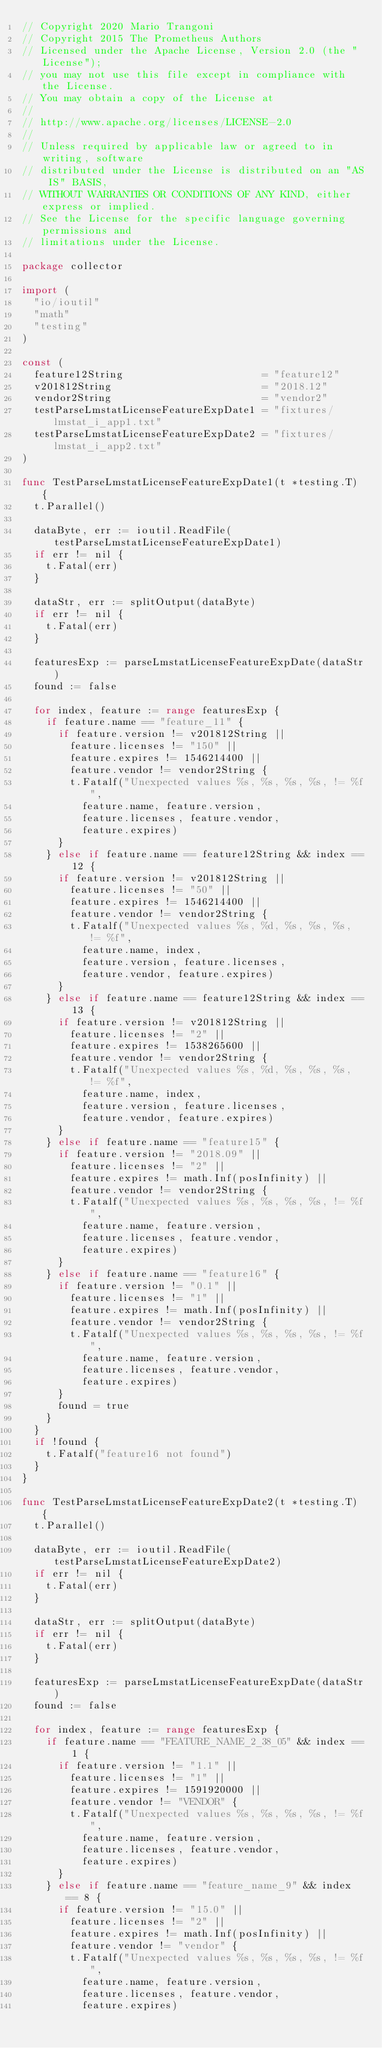<code> <loc_0><loc_0><loc_500><loc_500><_Go_>// Copyright 2020 Mario Trangoni
// Copyright 2015 The Prometheus Authors
// Licensed under the Apache License, Version 2.0 (the "License");
// you may not use this file except in compliance with the License.
// You may obtain a copy of the License at
//
// http://www.apache.org/licenses/LICENSE-2.0
//
// Unless required by applicable law or agreed to in writing, software
// distributed under the License is distributed on an "AS IS" BASIS,
// WITHOUT WARRANTIES OR CONDITIONS OF ANY KIND, either express or implied.
// See the License for the specific language governing permissions and
// limitations under the License.

package collector

import (
	"io/ioutil"
	"math"
	"testing"
)

const (
	feature12String                       = "feature12"
	v201812String                         = "2018.12"
	vendor2String                         = "vendor2"
	testParseLmstatLicenseFeatureExpDate1 = "fixtures/lmstat_i_app1.txt"
	testParseLmstatLicenseFeatureExpDate2 = "fixtures/lmstat_i_app2.txt"
)

func TestParseLmstatLicenseFeatureExpDate1(t *testing.T) {
	t.Parallel()

	dataByte, err := ioutil.ReadFile(testParseLmstatLicenseFeatureExpDate1)
	if err != nil {
		t.Fatal(err)
	}

	dataStr, err := splitOutput(dataByte)
	if err != nil {
		t.Fatal(err)
	}

	featuresExp := parseLmstatLicenseFeatureExpDate(dataStr)
	found := false

	for index, feature := range featuresExp {
		if feature.name == "feature_11" {
			if feature.version != v201812String ||
				feature.licenses != "150" ||
				feature.expires != 1546214400 ||
				feature.vendor != vendor2String {
				t.Fatalf("Unexpected values %s, %s, %s, %s, != %f",
					feature.name, feature.version,
					feature.licenses, feature.vendor,
					feature.expires)
			}
		} else if feature.name == feature12String && index == 12 {
			if feature.version != v201812String ||
				feature.licenses != "50" ||
				feature.expires != 1546214400 ||
				feature.vendor != vendor2String {
				t.Fatalf("Unexpected values %s, %d, %s, %s, %s, != %f",
					feature.name, index,
					feature.version, feature.licenses,
					feature.vendor, feature.expires)
			}
		} else if feature.name == feature12String && index == 13 {
			if feature.version != v201812String ||
				feature.licenses != "2" ||
				feature.expires != 1538265600 ||
				feature.vendor != vendor2String {
				t.Fatalf("Unexpected values %s, %d, %s, %s, %s, != %f",
					feature.name, index,
					feature.version, feature.licenses,
					feature.vendor, feature.expires)
			}
		} else if feature.name == "feature15" {
			if feature.version != "2018.09" ||
				feature.licenses != "2" ||
				feature.expires != math.Inf(posInfinity) ||
				feature.vendor != vendor2String {
				t.Fatalf("Unexpected values %s, %s, %s, %s, != %f",
					feature.name, feature.version,
					feature.licenses, feature.vendor,
					feature.expires)
			}
		} else if feature.name == "feature16" {
			if feature.version != "0.1" ||
				feature.licenses != "1" ||
				feature.expires != math.Inf(posInfinity) ||
				feature.vendor != vendor2String {
				t.Fatalf("Unexpected values %s, %s, %s, %s, != %f",
					feature.name, feature.version,
					feature.licenses, feature.vendor,
					feature.expires)
			}
			found = true
		}
	}
	if !found {
		t.Fatalf("feature16 not found")
	}
}

func TestParseLmstatLicenseFeatureExpDate2(t *testing.T) {
	t.Parallel()

	dataByte, err := ioutil.ReadFile(testParseLmstatLicenseFeatureExpDate2)
	if err != nil {
		t.Fatal(err)
	}

	dataStr, err := splitOutput(dataByte)
	if err != nil {
		t.Fatal(err)
	}

	featuresExp := parseLmstatLicenseFeatureExpDate(dataStr)
	found := false

	for index, feature := range featuresExp {
		if feature.name == "FEATURE_NAME_2_38_05" && index == 1 {
			if feature.version != "1.1" ||
				feature.licenses != "1" ||
				feature.expires != 1591920000 ||
				feature.vendor != "VENDOR" {
				t.Fatalf("Unexpected values %s, %s, %s, %s, != %f",
					feature.name, feature.version,
					feature.licenses, feature.vendor,
					feature.expires)
			}
		} else if feature.name == "feature_name_9" && index == 8 {
			if feature.version != "15.0" ||
				feature.licenses != "2" ||
				feature.expires != math.Inf(posInfinity) ||
				feature.vendor != "vendor" {
				t.Fatalf("Unexpected values %s, %s, %s, %s, != %f",
					feature.name, feature.version,
					feature.licenses, feature.vendor,
					feature.expires)</code> 